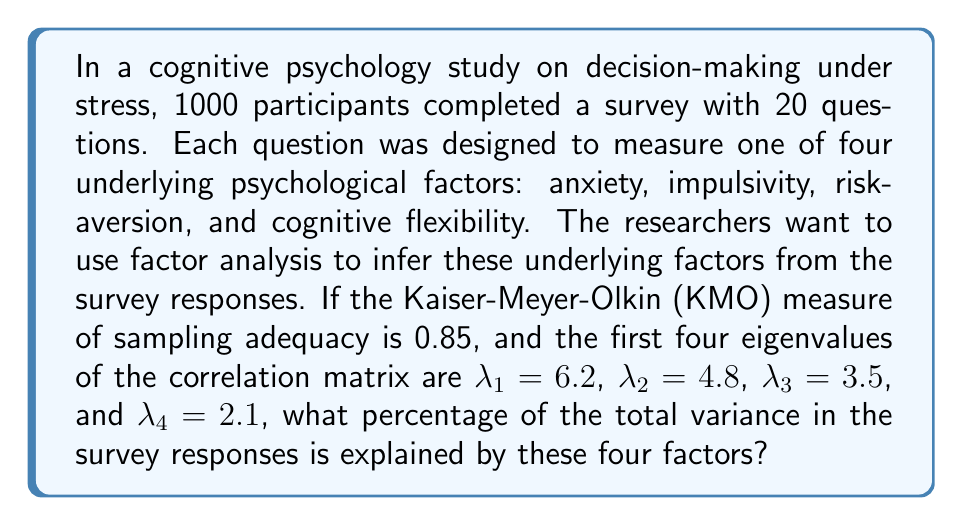Give your solution to this math problem. To solve this problem, we need to follow these steps:

1. Understand the context:
   - We have 20 survey questions (variables)
   - We're looking at the first four factors (eigenvalues)

2. Calculate the total variance:
   - In factor analysis, the total variance is equal to the number of variables
   - Total variance = 20

3. Calculate the variance explained by each factor:
   - The variance explained by each factor is equal to its eigenvalue
   - Factor 1: $\lambda_1 = 6.2$
   - Factor 2: $\lambda_2 = 4.8$
   - Factor 3: $\lambda_3 = 3.5$
   - Factor 4: $\lambda_4 = 2.1$

4. Sum the variance explained by the four factors:
   $$\text{Sum of variances} = 6.2 + 4.8 + 3.5 + 2.1 = 16.6$$

5. Calculate the percentage of total variance explained:
   $$\text{Percentage} = \frac{\text{Sum of variances}}{\text{Total variance}} \times 100\%$$
   $$\text{Percentage} = \frac{16.6}{20} \times 100\% = 83\%$$

Therefore, the four factors explain 83% of the total variance in the survey responses.
Answer: 83% 